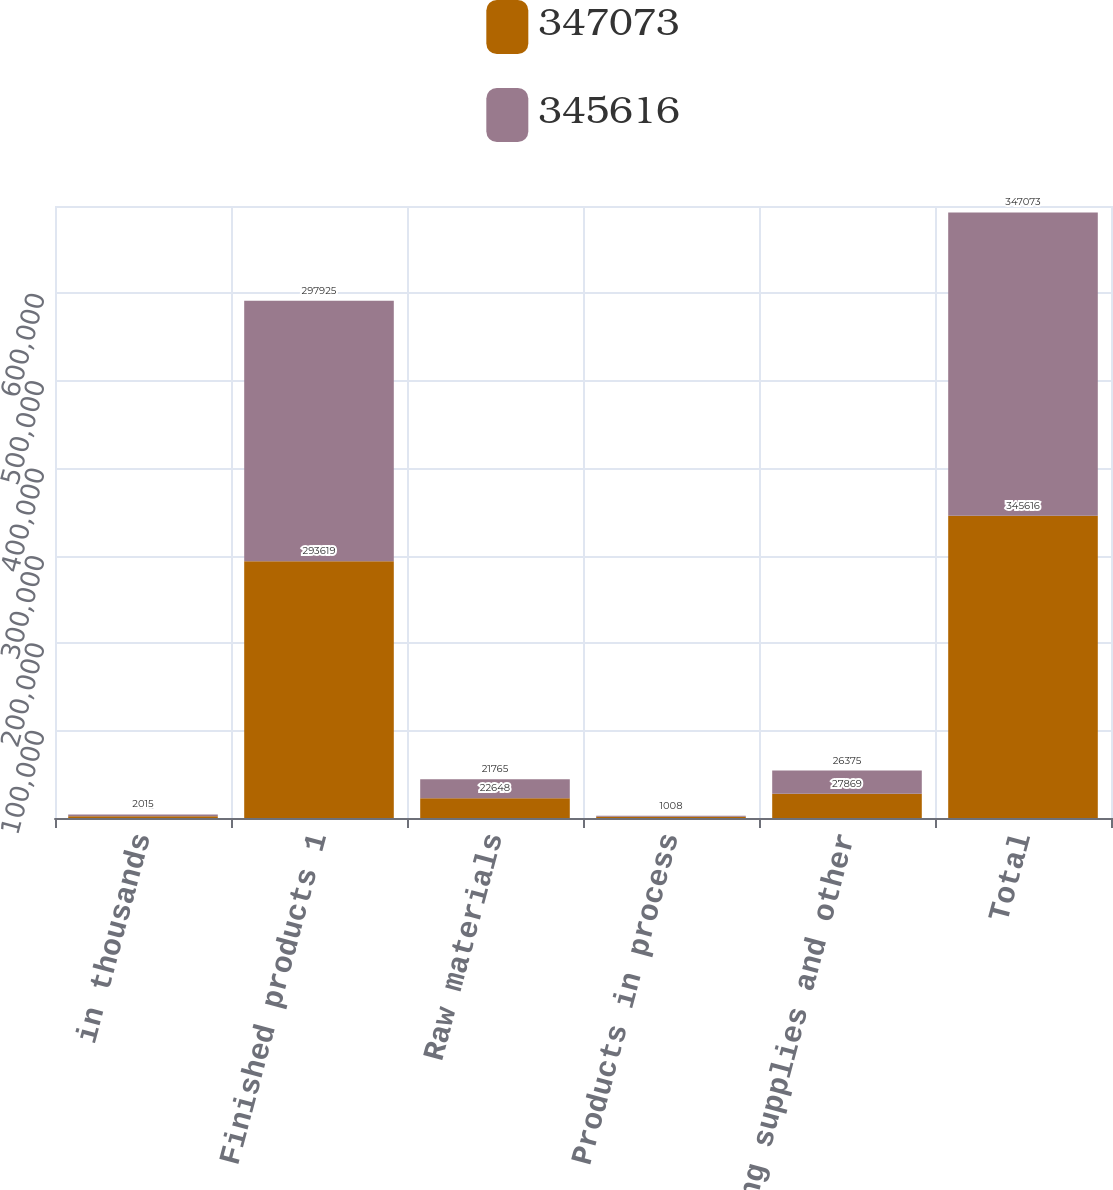Convert chart to OTSL. <chart><loc_0><loc_0><loc_500><loc_500><stacked_bar_chart><ecel><fcel>in thousands<fcel>Finished products 1<fcel>Raw materials<fcel>Products in process<fcel>Operating supplies and other<fcel>Total<nl><fcel>347073<fcel>2016<fcel>293619<fcel>22648<fcel>1480<fcel>27869<fcel>345616<nl><fcel>345616<fcel>2015<fcel>297925<fcel>21765<fcel>1008<fcel>26375<fcel>347073<nl></chart> 